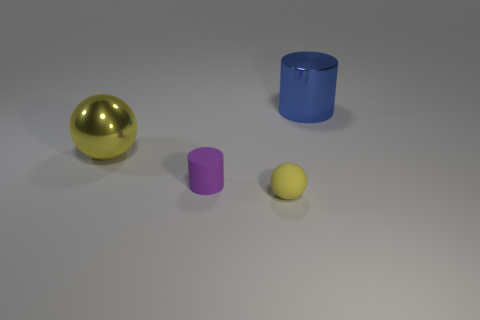Add 1 large blue metallic cylinders. How many objects exist? 5 Subtract 0 yellow cylinders. How many objects are left? 4 Subtract 2 cylinders. How many cylinders are left? 0 Subtract all red cylinders. Subtract all red balls. How many cylinders are left? 2 Subtract all cyan matte cylinders. Subtract all small yellow rubber balls. How many objects are left? 3 Add 4 yellow shiny spheres. How many yellow shiny spheres are left? 5 Add 3 large blue metal things. How many large blue metal things exist? 4 